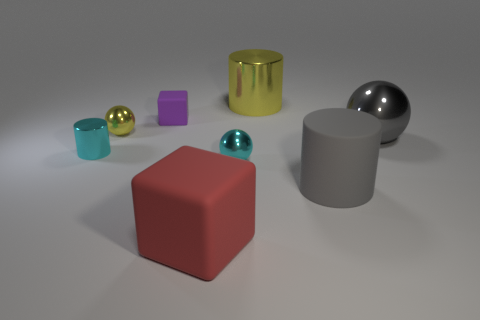Add 2 big cyan objects. How many objects exist? 10 Subtract all blocks. How many objects are left? 6 Subtract 0 gray blocks. How many objects are left? 8 Subtract all large yellow blocks. Subtract all small cyan cylinders. How many objects are left? 7 Add 7 small yellow things. How many small yellow things are left? 8 Add 6 tiny green rubber spheres. How many tiny green rubber spheres exist? 6 